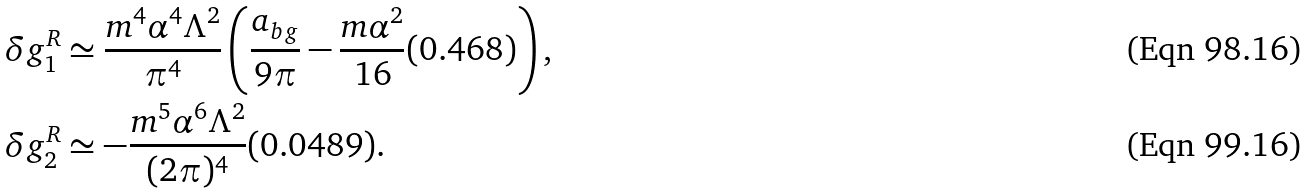<formula> <loc_0><loc_0><loc_500><loc_500>\delta g ^ { R } _ { 1 } & \simeq \frac { m ^ { 4 } \alpha ^ { 4 } \Lambda ^ { 2 } } { \pi ^ { 4 } } \left ( \frac { a _ { b g } } { 9 \pi } - \frac { m \alpha ^ { 2 } } { 1 6 } ( 0 . 4 6 8 ) \right ) , \\ \delta g ^ { R } _ { 2 } & \simeq - \frac { m ^ { 5 } \alpha ^ { 6 } \Lambda ^ { 2 } } { ( 2 \pi ) ^ { 4 } } ( 0 . 0 4 8 9 ) .</formula> 